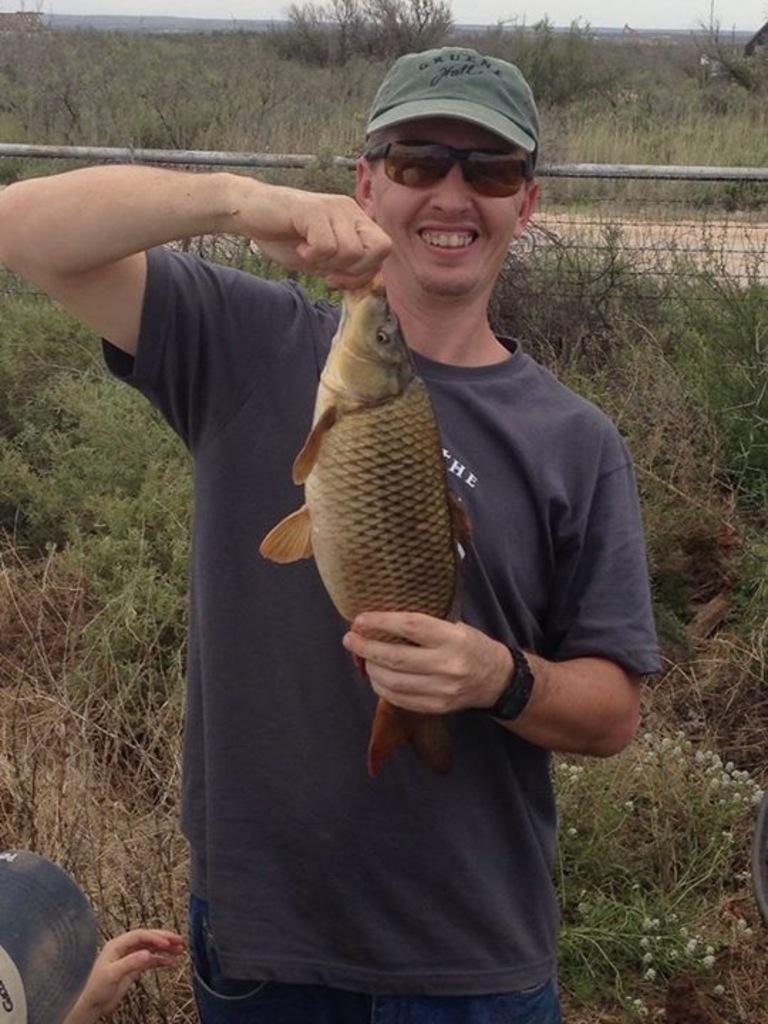Could you give a brief overview of what you see in this image? In this image, we can see some plants. There is a person wearing clothes and holding a fish with his hand. There is a fencing at the top of the image. There is a person hand and cap in the bottom left of the image. 